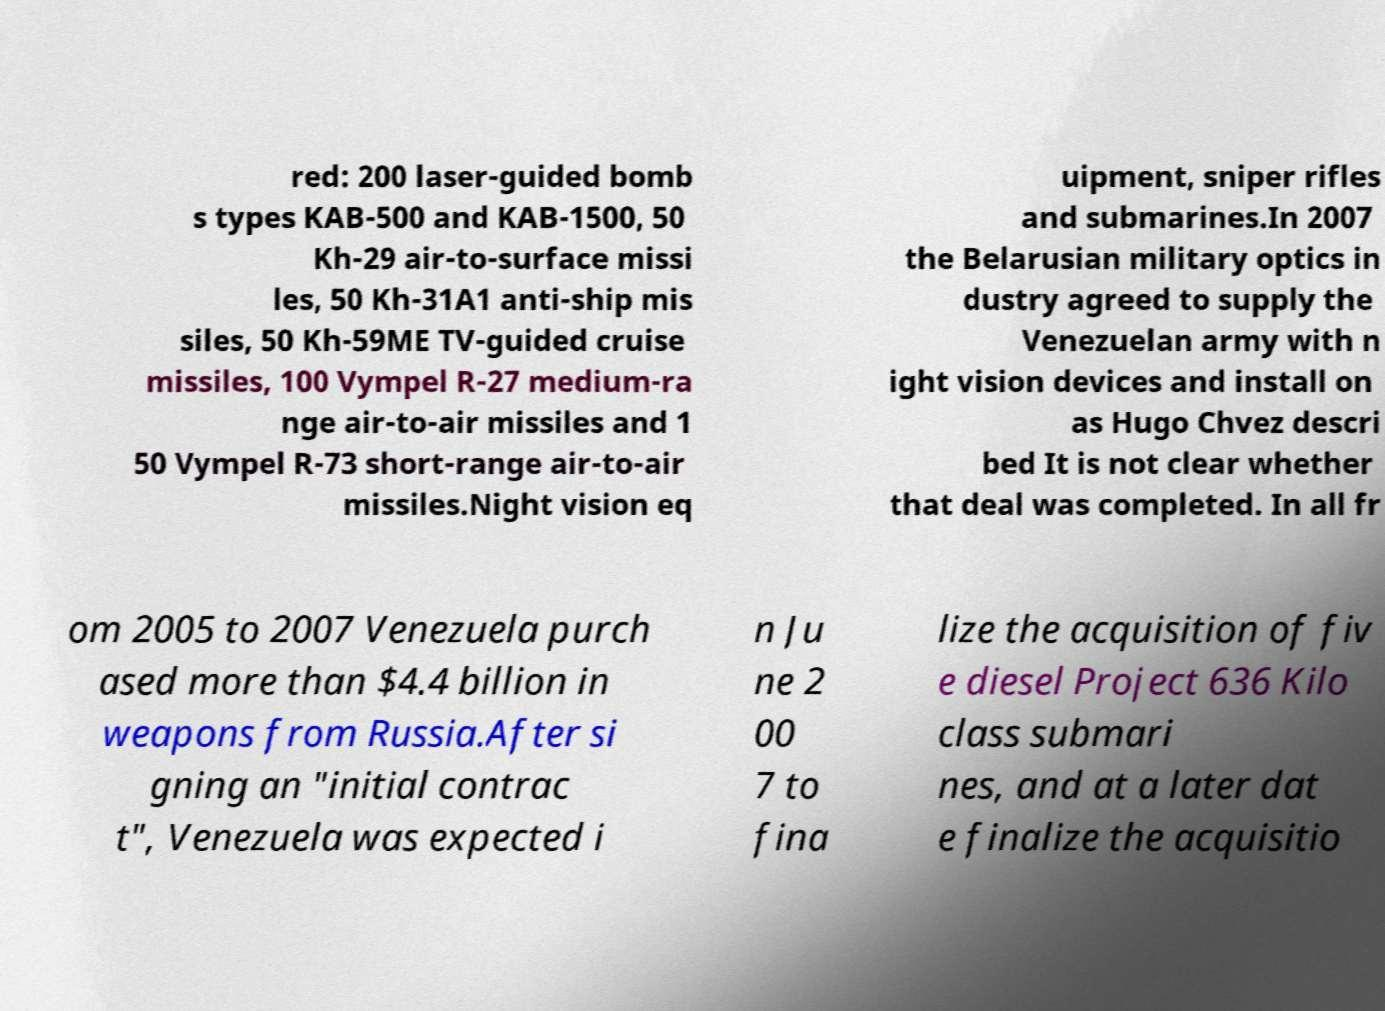Please read and relay the text visible in this image. What does it say? red: 200 laser-guided bomb s types KAB-500 and KAB-1500, 50 Kh-29 air-to-surface missi les, 50 Kh-31A1 anti-ship mis siles, 50 Kh-59ME TV-guided cruise missiles, 100 Vympel R-27 medium-ra nge air-to-air missiles and 1 50 Vympel R-73 short-range air-to-air missiles.Night vision eq uipment, sniper rifles and submarines.In 2007 the Belarusian military optics in dustry agreed to supply the Venezuelan army with n ight vision devices and install on as Hugo Chvez descri bed It is not clear whether that deal was completed. In all fr om 2005 to 2007 Venezuela purch ased more than $4.4 billion in weapons from Russia.After si gning an "initial contrac t", Venezuela was expected i n Ju ne 2 00 7 to fina lize the acquisition of fiv e diesel Project 636 Kilo class submari nes, and at a later dat e finalize the acquisitio 